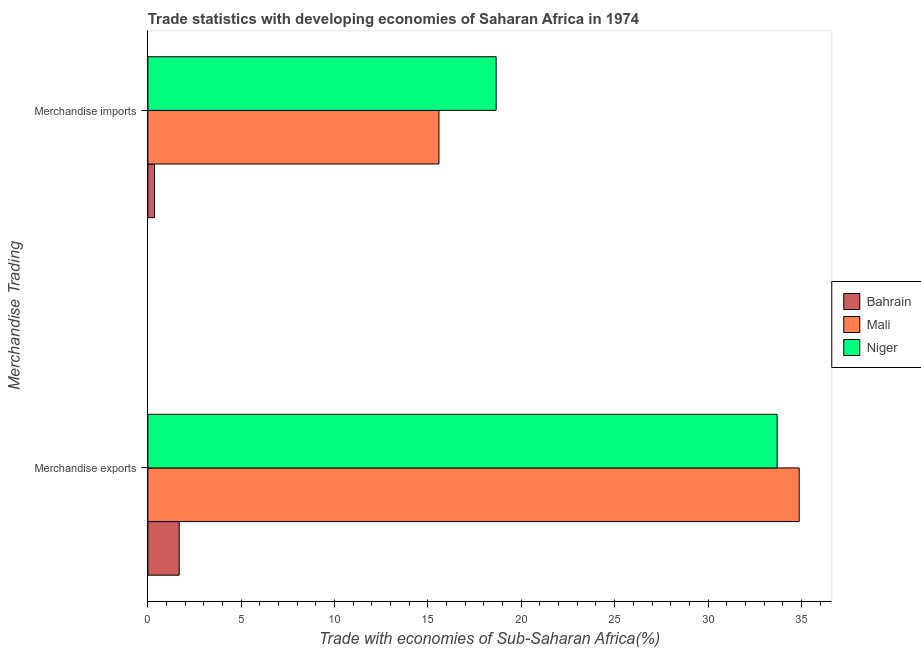How many groups of bars are there?
Provide a short and direct response. 2. Are the number of bars on each tick of the Y-axis equal?
Your answer should be very brief. Yes. How many bars are there on the 2nd tick from the top?
Offer a very short reply. 3. What is the merchandise imports in Mali?
Provide a short and direct response. 15.59. Across all countries, what is the maximum merchandise imports?
Your answer should be very brief. 18.65. Across all countries, what is the minimum merchandise exports?
Your answer should be compact. 1.68. In which country was the merchandise imports maximum?
Offer a very short reply. Niger. In which country was the merchandise imports minimum?
Provide a short and direct response. Bahrain. What is the total merchandise imports in the graph?
Ensure brevity in your answer.  34.6. What is the difference between the merchandise exports in Bahrain and that in Niger?
Keep it short and to the point. -32.02. What is the difference between the merchandise exports in Niger and the merchandise imports in Bahrain?
Offer a terse response. 33.35. What is the average merchandise imports per country?
Your answer should be compact. 11.53. What is the difference between the merchandise imports and merchandise exports in Mali?
Provide a succinct answer. -19.29. In how many countries, is the merchandise exports greater than 7 %?
Ensure brevity in your answer.  2. What is the ratio of the merchandise imports in Niger to that in Bahrain?
Offer a terse response. 52.38. Is the merchandise exports in Niger less than that in Mali?
Your response must be concise. Yes. In how many countries, is the merchandise exports greater than the average merchandise exports taken over all countries?
Your answer should be compact. 2. What does the 2nd bar from the top in Merchandise imports represents?
Provide a short and direct response. Mali. What does the 2nd bar from the bottom in Merchandise imports represents?
Provide a succinct answer. Mali. What is the difference between two consecutive major ticks on the X-axis?
Your answer should be very brief. 5. Does the graph contain grids?
Keep it short and to the point. No. Where does the legend appear in the graph?
Offer a very short reply. Center right. How many legend labels are there?
Keep it short and to the point. 3. How are the legend labels stacked?
Keep it short and to the point. Vertical. What is the title of the graph?
Give a very brief answer. Trade statistics with developing economies of Saharan Africa in 1974. What is the label or title of the X-axis?
Provide a short and direct response. Trade with economies of Sub-Saharan Africa(%). What is the label or title of the Y-axis?
Provide a succinct answer. Merchandise Trading. What is the Trade with economies of Sub-Saharan Africa(%) in Bahrain in Merchandise exports?
Offer a terse response. 1.68. What is the Trade with economies of Sub-Saharan Africa(%) of Mali in Merchandise exports?
Give a very brief answer. 34.88. What is the Trade with economies of Sub-Saharan Africa(%) in Niger in Merchandise exports?
Give a very brief answer. 33.7. What is the Trade with economies of Sub-Saharan Africa(%) of Bahrain in Merchandise imports?
Your answer should be compact. 0.36. What is the Trade with economies of Sub-Saharan Africa(%) in Mali in Merchandise imports?
Make the answer very short. 15.59. What is the Trade with economies of Sub-Saharan Africa(%) in Niger in Merchandise imports?
Your answer should be very brief. 18.65. Across all Merchandise Trading, what is the maximum Trade with economies of Sub-Saharan Africa(%) of Bahrain?
Give a very brief answer. 1.68. Across all Merchandise Trading, what is the maximum Trade with economies of Sub-Saharan Africa(%) of Mali?
Your answer should be compact. 34.88. Across all Merchandise Trading, what is the maximum Trade with economies of Sub-Saharan Africa(%) in Niger?
Your answer should be compact. 33.7. Across all Merchandise Trading, what is the minimum Trade with economies of Sub-Saharan Africa(%) of Bahrain?
Make the answer very short. 0.36. Across all Merchandise Trading, what is the minimum Trade with economies of Sub-Saharan Africa(%) in Mali?
Offer a very short reply. 15.59. Across all Merchandise Trading, what is the minimum Trade with economies of Sub-Saharan Africa(%) of Niger?
Your response must be concise. 18.65. What is the total Trade with economies of Sub-Saharan Africa(%) of Bahrain in the graph?
Offer a terse response. 2.03. What is the total Trade with economies of Sub-Saharan Africa(%) in Mali in the graph?
Keep it short and to the point. 50.47. What is the total Trade with economies of Sub-Saharan Africa(%) in Niger in the graph?
Your answer should be very brief. 52.35. What is the difference between the Trade with economies of Sub-Saharan Africa(%) in Bahrain in Merchandise exports and that in Merchandise imports?
Give a very brief answer. 1.32. What is the difference between the Trade with economies of Sub-Saharan Africa(%) of Mali in Merchandise exports and that in Merchandise imports?
Your response must be concise. 19.29. What is the difference between the Trade with economies of Sub-Saharan Africa(%) in Niger in Merchandise exports and that in Merchandise imports?
Give a very brief answer. 15.05. What is the difference between the Trade with economies of Sub-Saharan Africa(%) in Bahrain in Merchandise exports and the Trade with economies of Sub-Saharan Africa(%) in Mali in Merchandise imports?
Provide a short and direct response. -13.91. What is the difference between the Trade with economies of Sub-Saharan Africa(%) of Bahrain in Merchandise exports and the Trade with economies of Sub-Saharan Africa(%) of Niger in Merchandise imports?
Offer a terse response. -16.98. What is the difference between the Trade with economies of Sub-Saharan Africa(%) in Mali in Merchandise exports and the Trade with economies of Sub-Saharan Africa(%) in Niger in Merchandise imports?
Your answer should be compact. 16.23. What is the average Trade with economies of Sub-Saharan Africa(%) in Bahrain per Merchandise Trading?
Ensure brevity in your answer.  1.02. What is the average Trade with economies of Sub-Saharan Africa(%) in Mali per Merchandise Trading?
Offer a terse response. 25.24. What is the average Trade with economies of Sub-Saharan Africa(%) in Niger per Merchandise Trading?
Your response must be concise. 26.18. What is the difference between the Trade with economies of Sub-Saharan Africa(%) of Bahrain and Trade with economies of Sub-Saharan Africa(%) of Mali in Merchandise exports?
Make the answer very short. -33.21. What is the difference between the Trade with economies of Sub-Saharan Africa(%) of Bahrain and Trade with economies of Sub-Saharan Africa(%) of Niger in Merchandise exports?
Make the answer very short. -32.02. What is the difference between the Trade with economies of Sub-Saharan Africa(%) of Mali and Trade with economies of Sub-Saharan Africa(%) of Niger in Merchandise exports?
Ensure brevity in your answer.  1.18. What is the difference between the Trade with economies of Sub-Saharan Africa(%) in Bahrain and Trade with economies of Sub-Saharan Africa(%) in Mali in Merchandise imports?
Keep it short and to the point. -15.23. What is the difference between the Trade with economies of Sub-Saharan Africa(%) in Bahrain and Trade with economies of Sub-Saharan Africa(%) in Niger in Merchandise imports?
Your answer should be very brief. -18.3. What is the difference between the Trade with economies of Sub-Saharan Africa(%) of Mali and Trade with economies of Sub-Saharan Africa(%) of Niger in Merchandise imports?
Provide a short and direct response. -3.06. What is the ratio of the Trade with economies of Sub-Saharan Africa(%) of Bahrain in Merchandise exports to that in Merchandise imports?
Keep it short and to the point. 4.71. What is the ratio of the Trade with economies of Sub-Saharan Africa(%) in Mali in Merchandise exports to that in Merchandise imports?
Offer a very short reply. 2.24. What is the ratio of the Trade with economies of Sub-Saharan Africa(%) of Niger in Merchandise exports to that in Merchandise imports?
Your response must be concise. 1.81. What is the difference between the highest and the second highest Trade with economies of Sub-Saharan Africa(%) in Bahrain?
Your answer should be very brief. 1.32. What is the difference between the highest and the second highest Trade with economies of Sub-Saharan Africa(%) in Mali?
Give a very brief answer. 19.29. What is the difference between the highest and the second highest Trade with economies of Sub-Saharan Africa(%) of Niger?
Provide a short and direct response. 15.05. What is the difference between the highest and the lowest Trade with economies of Sub-Saharan Africa(%) of Bahrain?
Offer a very short reply. 1.32. What is the difference between the highest and the lowest Trade with economies of Sub-Saharan Africa(%) in Mali?
Provide a short and direct response. 19.29. What is the difference between the highest and the lowest Trade with economies of Sub-Saharan Africa(%) in Niger?
Offer a very short reply. 15.05. 